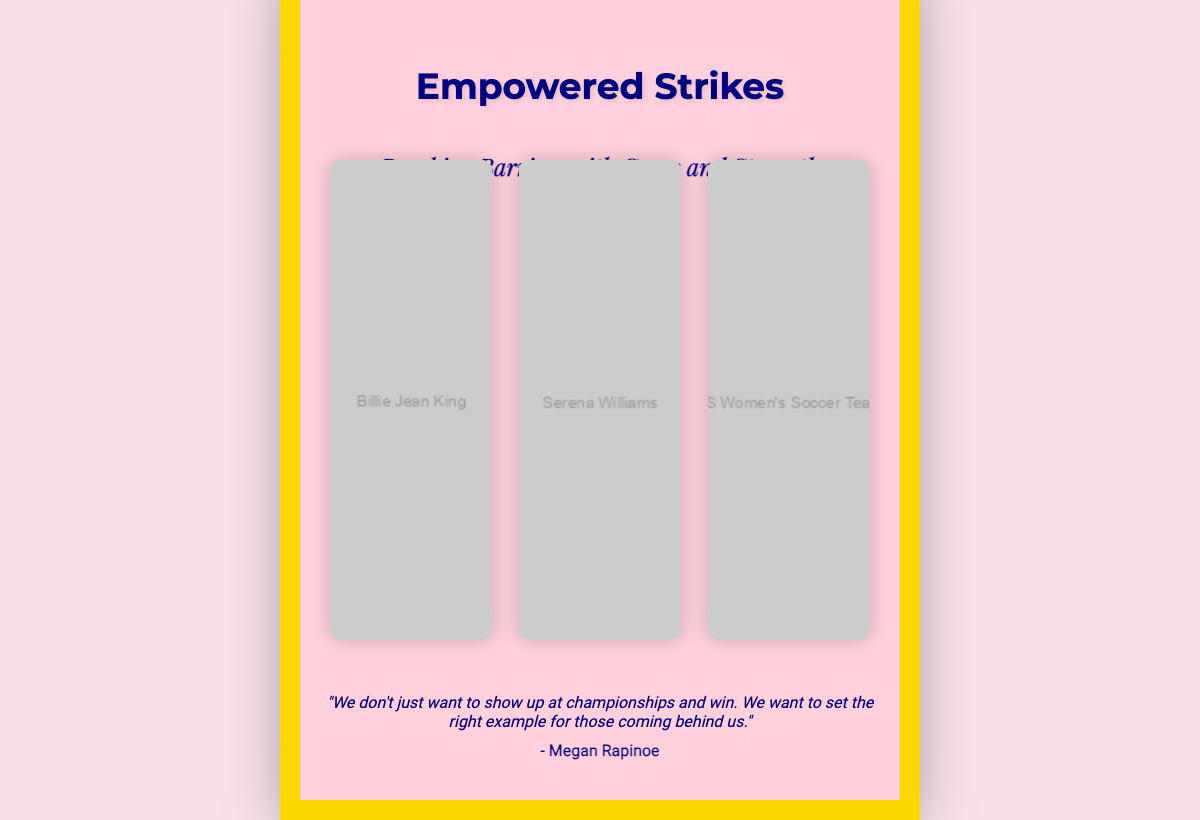What is the title of the book? The title of the book is prominently displayed at the top of the cover.
Answer: Empowered Strikes Who is featured in the first image of the collage? The first image in the collage shows a famous female athlete.
Answer: Billie Jean King What is the subtitle of the book? The subtitle provides further context about the theme and tone of the book cover.
Answer: Breaking Barriers with Grace and Strength What quote is included on the cover? The quote highlights the mission and impact of women in sports.
Answer: "We don't just want to show up at championships and win. We want to set the right example for those coming behind us." Who is the author of the quote? The author of the quote is a well-known figure in women's sports, signifying her influence.
Answer: Megan Rapinoe How many images are in the collage? The collage is designed to showcase multiple prominent moments in women's sports through imagery.
Answer: 3 What color is the background of the book cover? The background color helps to create a certain mood and aesthetic for the cover.
Answer: #ffd1dc What theme does the book cover convey? The imagery and typography together suggest a strong and uplifting message in women's sports.
Answer: Empowerment 